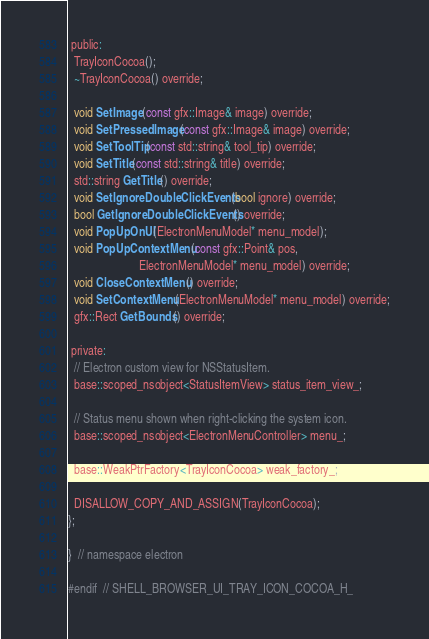Convert code to text. <code><loc_0><loc_0><loc_500><loc_500><_C_> public:
  TrayIconCocoa();
  ~TrayIconCocoa() override;

  void SetImage(const gfx::Image& image) override;
  void SetPressedImage(const gfx::Image& image) override;
  void SetToolTip(const std::string& tool_tip) override;
  void SetTitle(const std::string& title) override;
  std::string GetTitle() override;
  void SetIgnoreDoubleClickEvents(bool ignore) override;
  bool GetIgnoreDoubleClickEvents() override;
  void PopUpOnUI(ElectronMenuModel* menu_model);
  void PopUpContextMenu(const gfx::Point& pos,
                        ElectronMenuModel* menu_model) override;
  void CloseContextMenu() override;
  void SetContextMenu(ElectronMenuModel* menu_model) override;
  gfx::Rect GetBounds() override;

 private:
  // Electron custom view for NSStatusItem.
  base::scoped_nsobject<StatusItemView> status_item_view_;

  // Status menu shown when right-clicking the system icon.
  base::scoped_nsobject<ElectronMenuController> menu_;

  base::WeakPtrFactory<TrayIconCocoa> weak_factory_;

  DISALLOW_COPY_AND_ASSIGN(TrayIconCocoa);
};

}  // namespace electron

#endif  // SHELL_BROWSER_UI_TRAY_ICON_COCOA_H_
</code> 